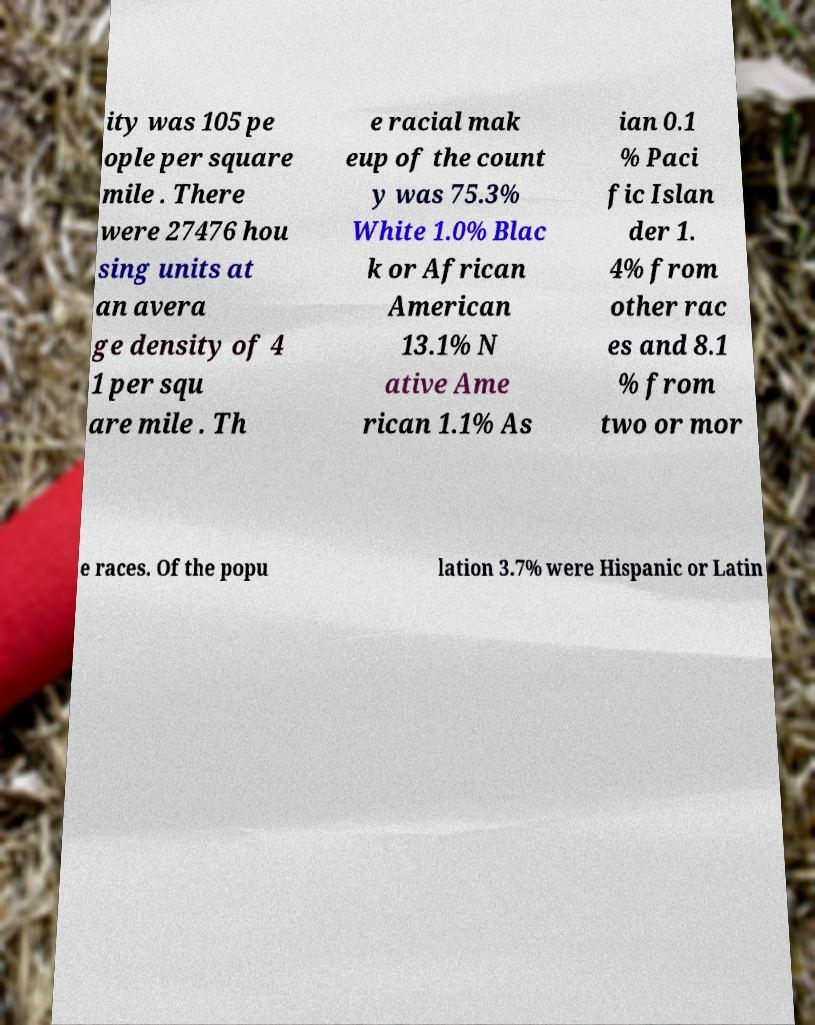For documentation purposes, I need the text within this image transcribed. Could you provide that? ity was 105 pe ople per square mile . There were 27476 hou sing units at an avera ge density of 4 1 per squ are mile . Th e racial mak eup of the count y was 75.3% White 1.0% Blac k or African American 13.1% N ative Ame rican 1.1% As ian 0.1 % Paci fic Islan der 1. 4% from other rac es and 8.1 % from two or mor e races. Of the popu lation 3.7% were Hispanic or Latin 